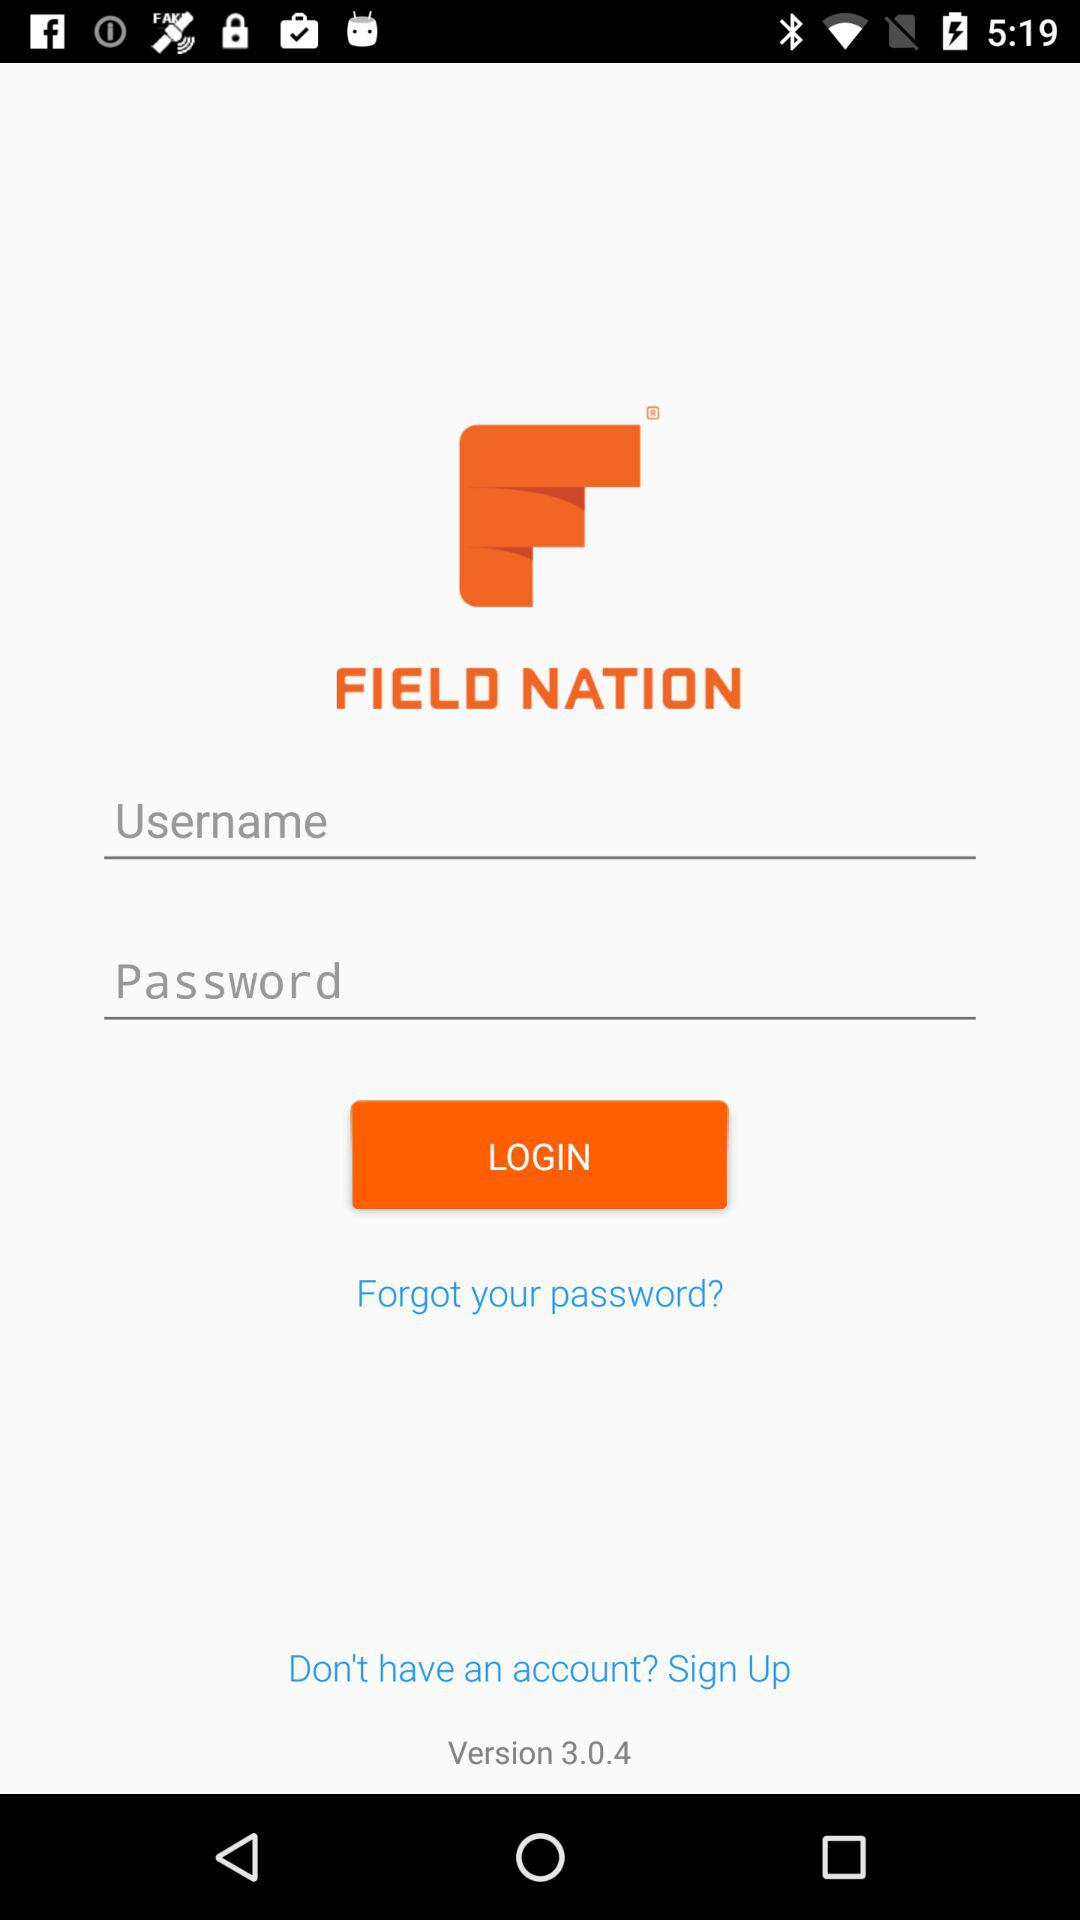What is the name of the application? The name of the application is "FIELD NATION". 